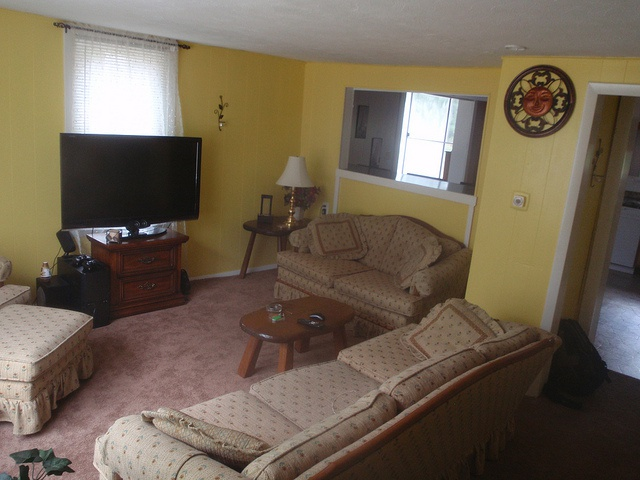Describe the objects in this image and their specific colors. I can see couch in darkgray, black, and gray tones, couch in darkgray, maroon, gray, and black tones, tv in darkgray, black, and gray tones, couch in darkgray, maroon, and black tones, and potted plant in darkgray, gray, and black tones in this image. 